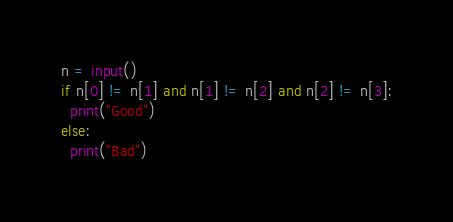<code> <loc_0><loc_0><loc_500><loc_500><_Python_>n = input()
if n[0] != n[1] and n[1] != n[2] and n[2] != n[3]:
  print("Good")
else:
  print("Bad")
</code> 